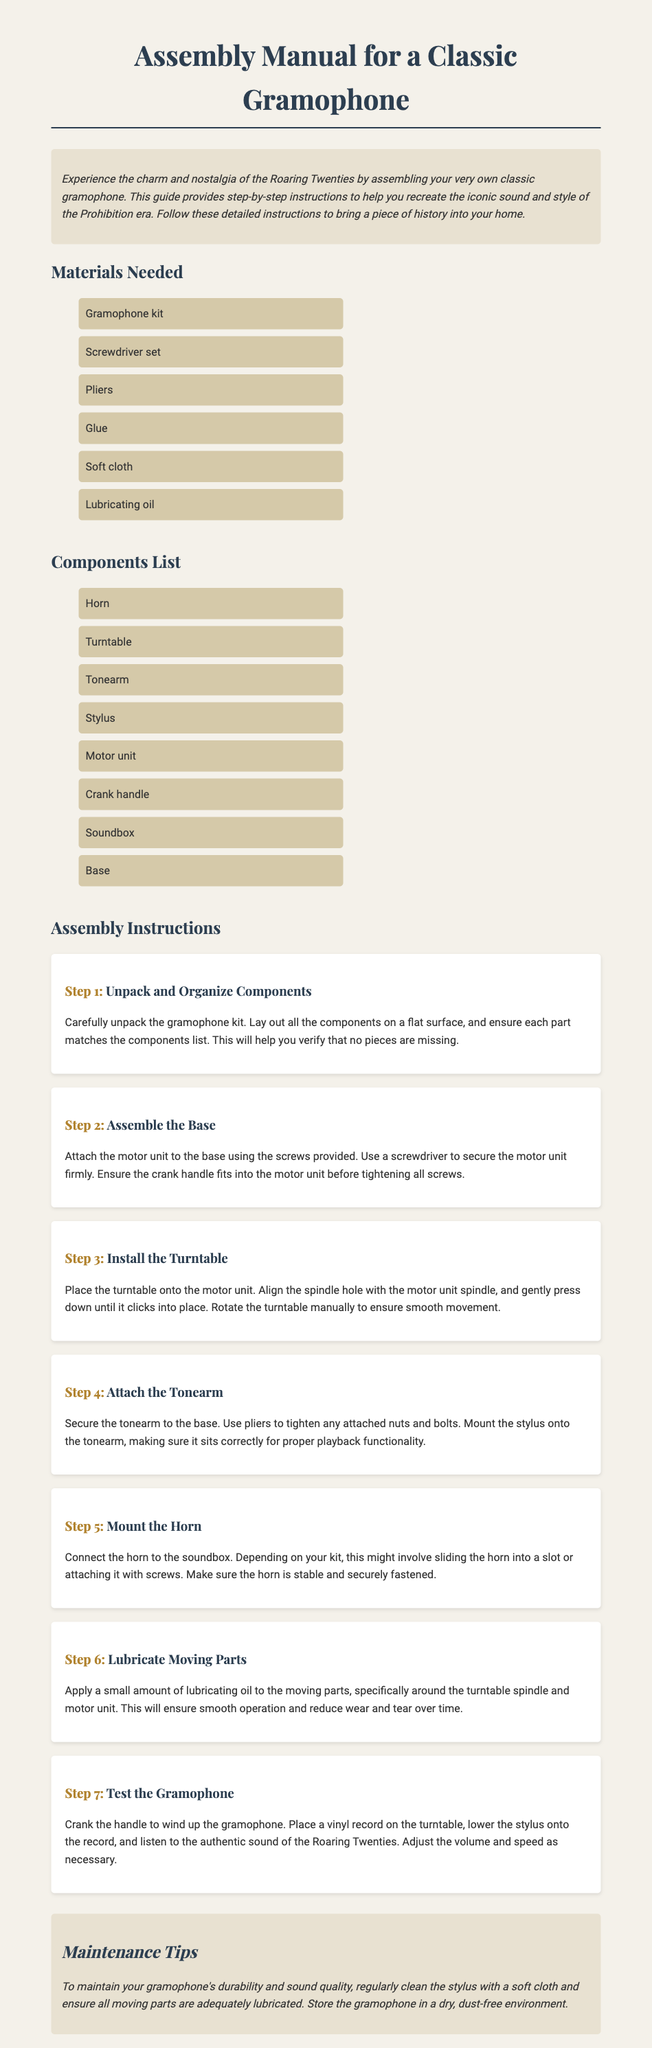What is the title of the document? The title of the document is indicated in the HTML head section and on the main page.
Answer: Assembly Manual for a Classic Gramophone How many materials are listed? The materials section lists all the items needed for assembly, which can be counted directly.
Answer: 6 What is the first step in the assembly instructions? The first step is described in the first instruction section, detailing the initial action.
Answer: Unpack and Organize Components Which component is mounted last in the assembly process? The assembly instructions outline the order, and the last component mentioned is the horn.
Answer: Horn What should be used to tighten the tonearm? The instructions specify the tool required for this particular assembly step.
Answer: Pliers What is the purpose of lubricating the moving parts? The maintenance section discusses lubrication and its benefits for the gramophone.
Answer: Ensure smooth operation How often should the stylus be cleaned? While not explicitly stated, the maintenance tips imply a regular routine for care.
Answer: Regularly What era does the gramophone represent? The introduction provides context regarding the historical significance and period associated with the gramophone.
Answer: Roaring Twenties What does the maintenance section recommend for storage? The maintenance section advises on conditions for storing the gramophone.
Answer: Dry, dust-free environment 